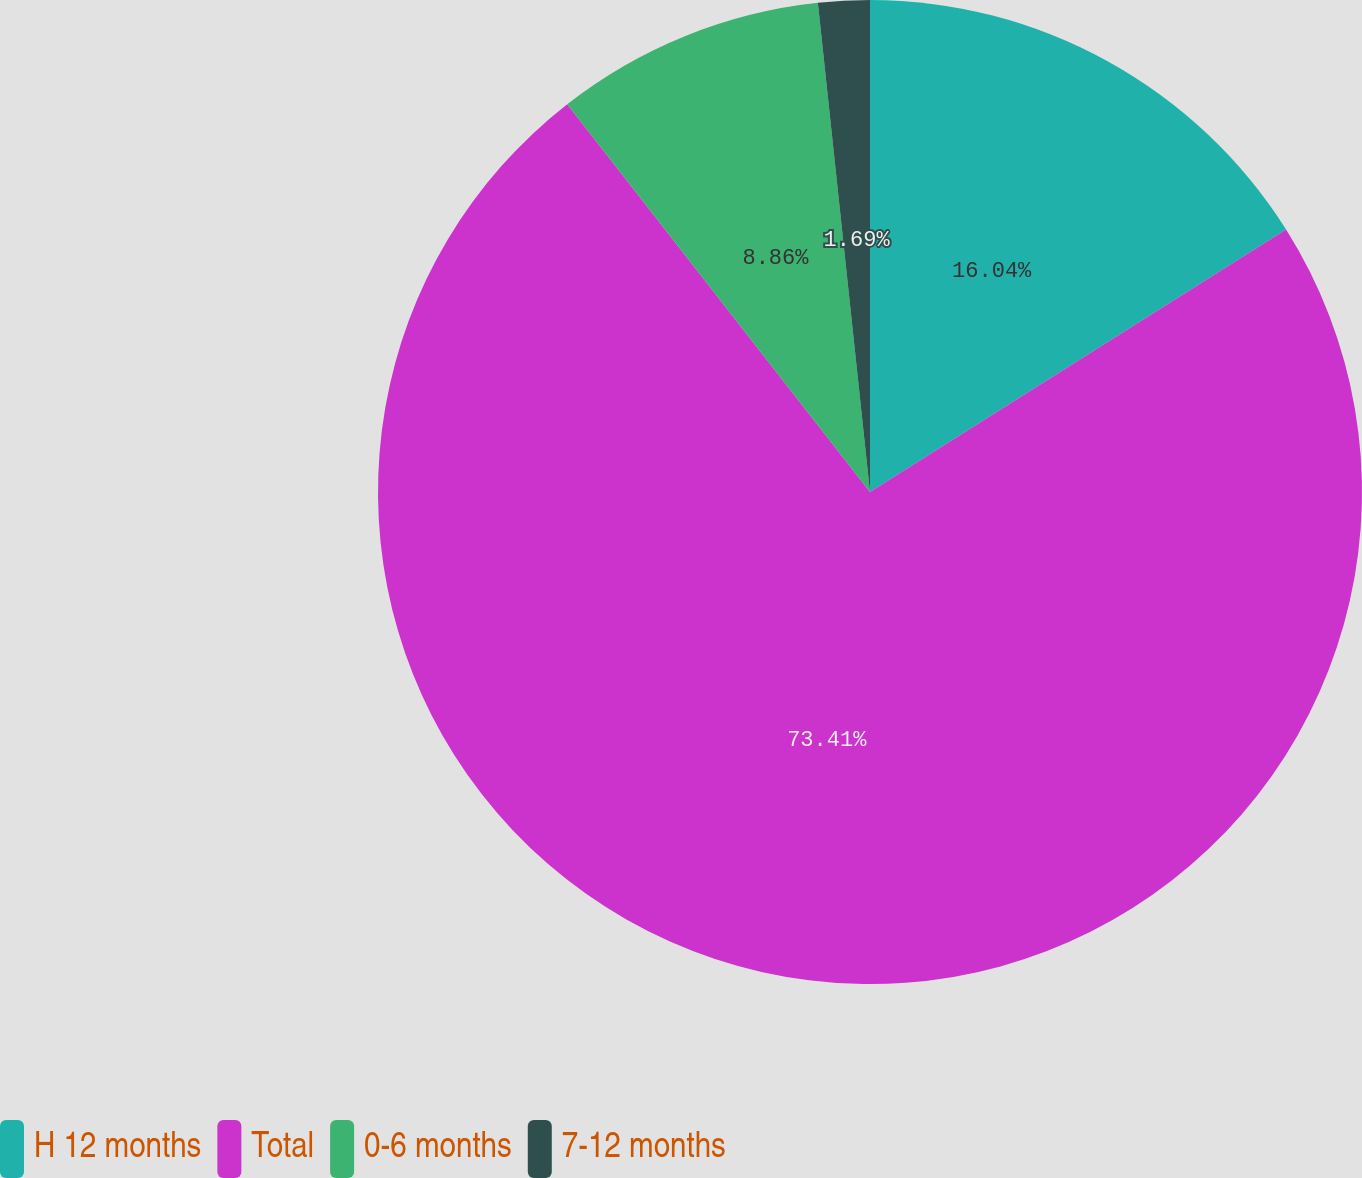<chart> <loc_0><loc_0><loc_500><loc_500><pie_chart><fcel>H 12 months<fcel>Total<fcel>0-6 months<fcel>7-12 months<nl><fcel>16.04%<fcel>73.41%<fcel>8.86%<fcel>1.69%<nl></chart> 